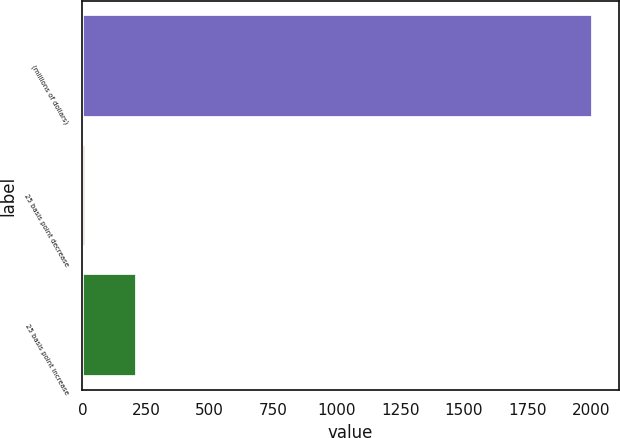Convert chart. <chart><loc_0><loc_0><loc_500><loc_500><bar_chart><fcel>(millions of dollars)<fcel>25 basis point decrease<fcel>25 basis point increase<nl><fcel>2010<fcel>14.1<fcel>213.69<nl></chart> 